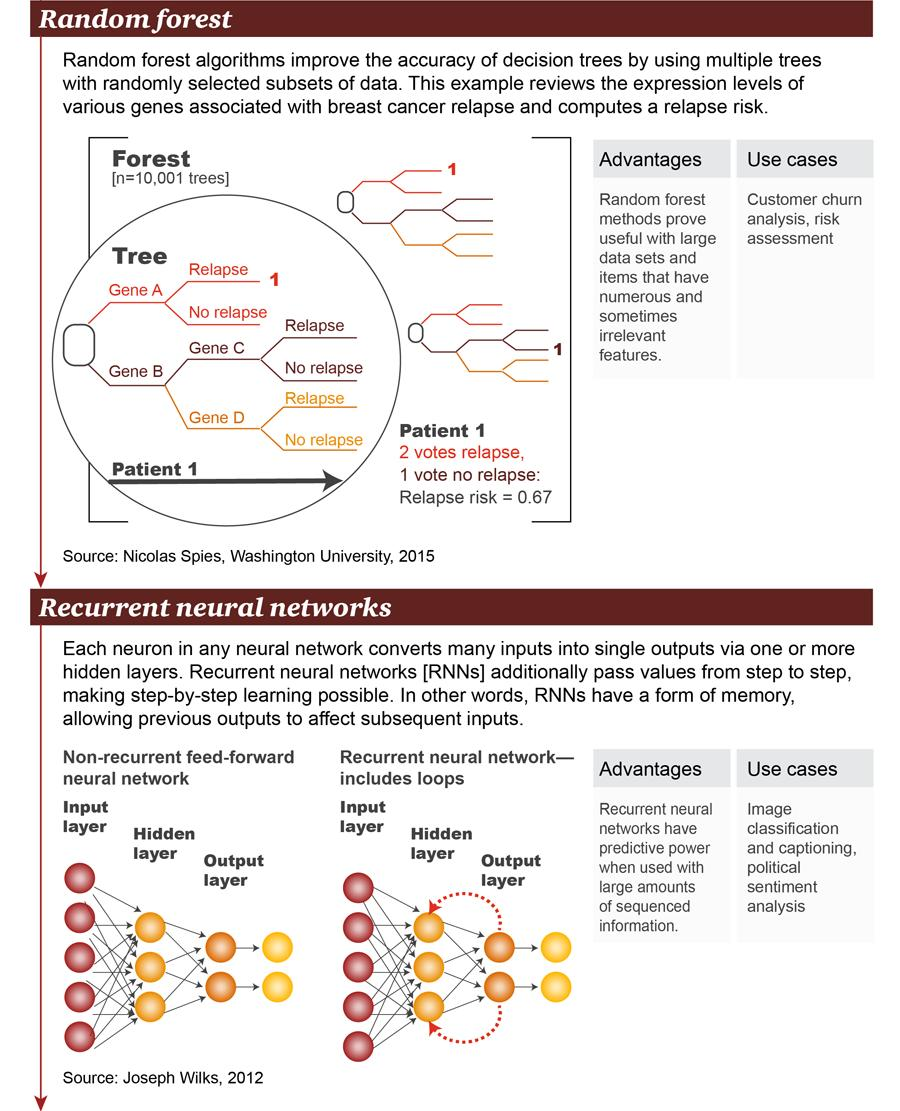Draw attention to some important aspects in this diagram. The color given to Gene D- is yellow. Neural networks have multiple layers that are organized in a specific way to process and analyze data. The layers of a neural network include the input layer, the hidden layers, and the output layer. The input layer receives the input data, the hidden layers process the input data to extract features, and the output layer produces the final output. The genes originating from Gene B are Gene C, Gene D, and any other genes that may have been derived from Gene B. The hidden layer is the middle layer of a neural network, responsible for processing and transmitting information. The genes A and B are derived from the root of the tree. 